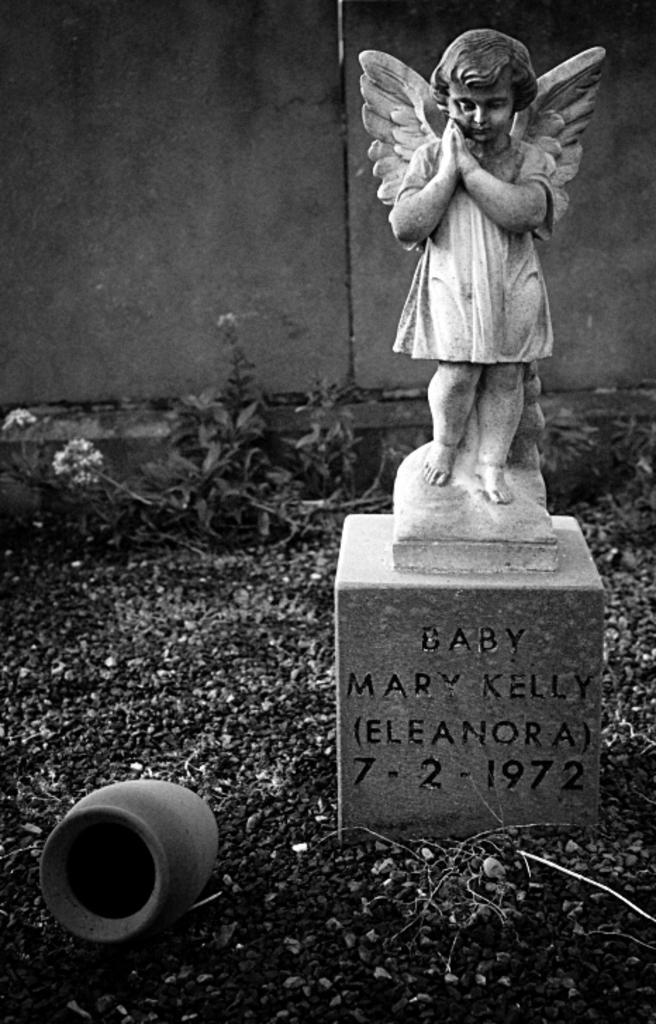Could you give a brief overview of what you see in this image? In this picture we can see sculpture on the platform and we can see pot on the ground. In the background of the image we can see plants and wall. 